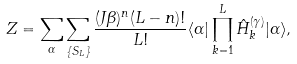Convert formula to latex. <formula><loc_0><loc_0><loc_500><loc_500>Z = \sum _ { \alpha } \sum _ { \{ S _ { L } \} } \frac { ( J \beta ) ^ { n } ( L - n ) ! } { L ! } \langle \alpha | \prod _ { k = 1 } ^ { L } \hat { H } ^ { ( \gamma ) } _ { k } | \alpha \rangle ,</formula> 